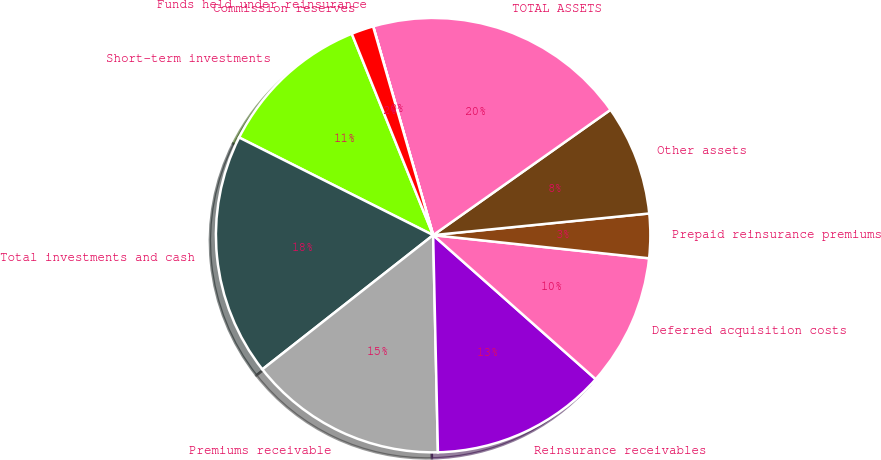Convert chart to OTSL. <chart><loc_0><loc_0><loc_500><loc_500><pie_chart><fcel>Short-term investments<fcel>Total investments and cash<fcel>Premiums receivable<fcel>Reinsurance receivables<fcel>Deferred acquisition costs<fcel>Prepaid reinsurance premiums<fcel>Other assets<fcel>TOTAL ASSETS<fcel>Funds held under reinsurance<fcel>Commission reserves<nl><fcel>11.47%<fcel>18.02%<fcel>14.75%<fcel>13.11%<fcel>9.84%<fcel>3.29%<fcel>8.2%<fcel>19.66%<fcel>0.01%<fcel>1.65%<nl></chart> 